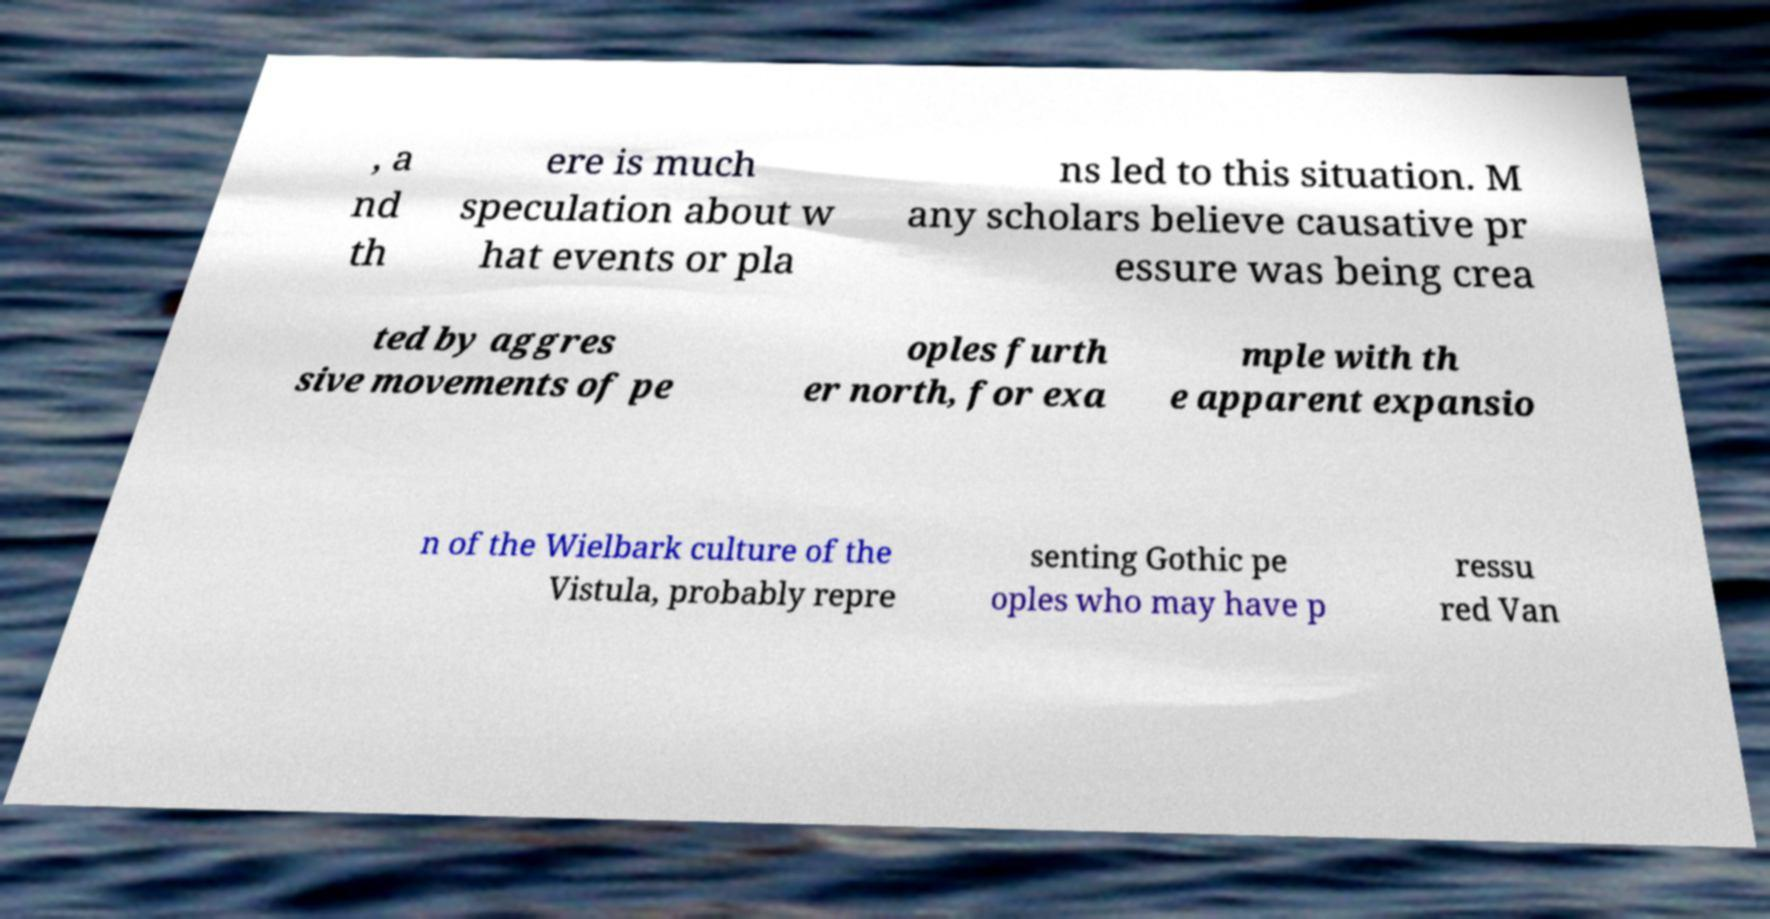I need the written content from this picture converted into text. Can you do that? , a nd th ere is much speculation about w hat events or pla ns led to this situation. M any scholars believe causative pr essure was being crea ted by aggres sive movements of pe oples furth er north, for exa mple with th e apparent expansio n of the Wielbark culture of the Vistula, probably repre senting Gothic pe oples who may have p ressu red Van 